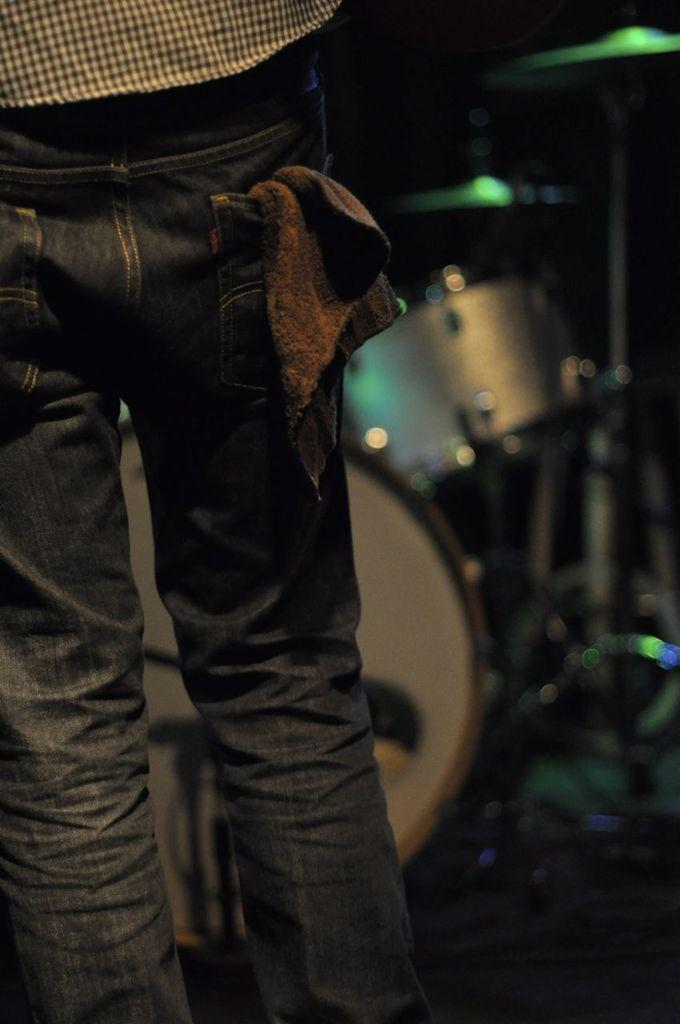What is the main subject of the image? There is a person standing in the image. What type of clothing is the person wearing? The person is wearing pants. What can be seen in the background of the image? There are musical instruments in the background of the image. What type of jam is being spread on the foot in the image? There is no foot or jam present in the image; it features a person standing and musical instruments in the background. 